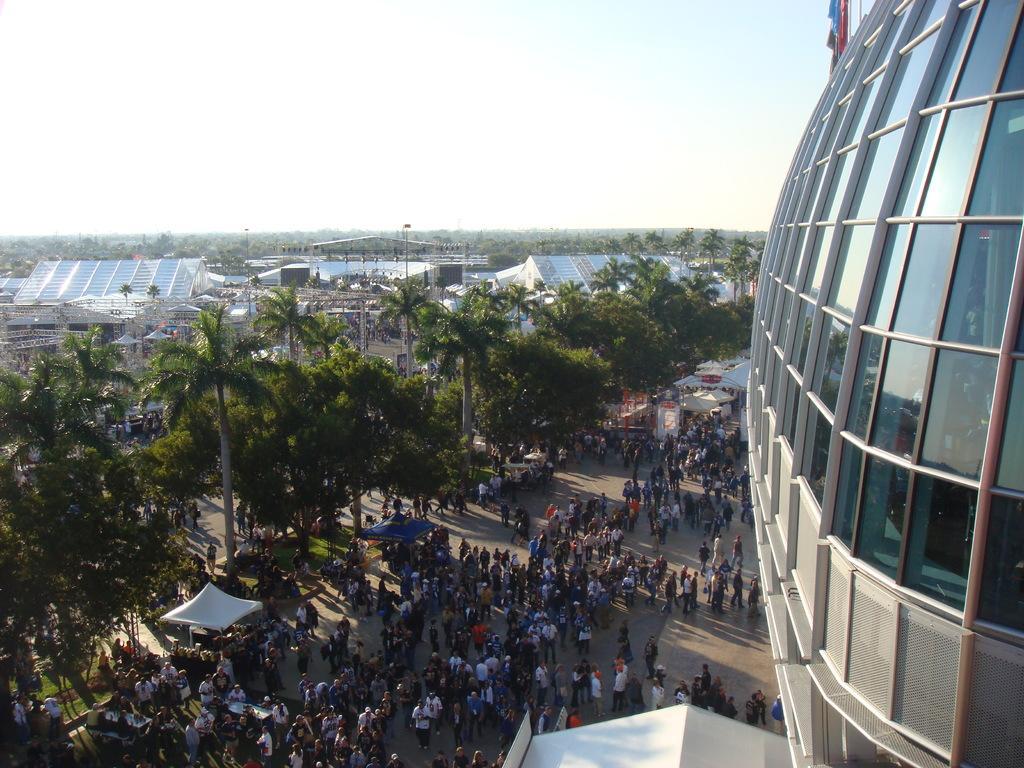Describe this image in one or two sentences. In this image I can see number of people are standing. I can also see few tenths, number of trees, number of buildings and I can see shadows. 